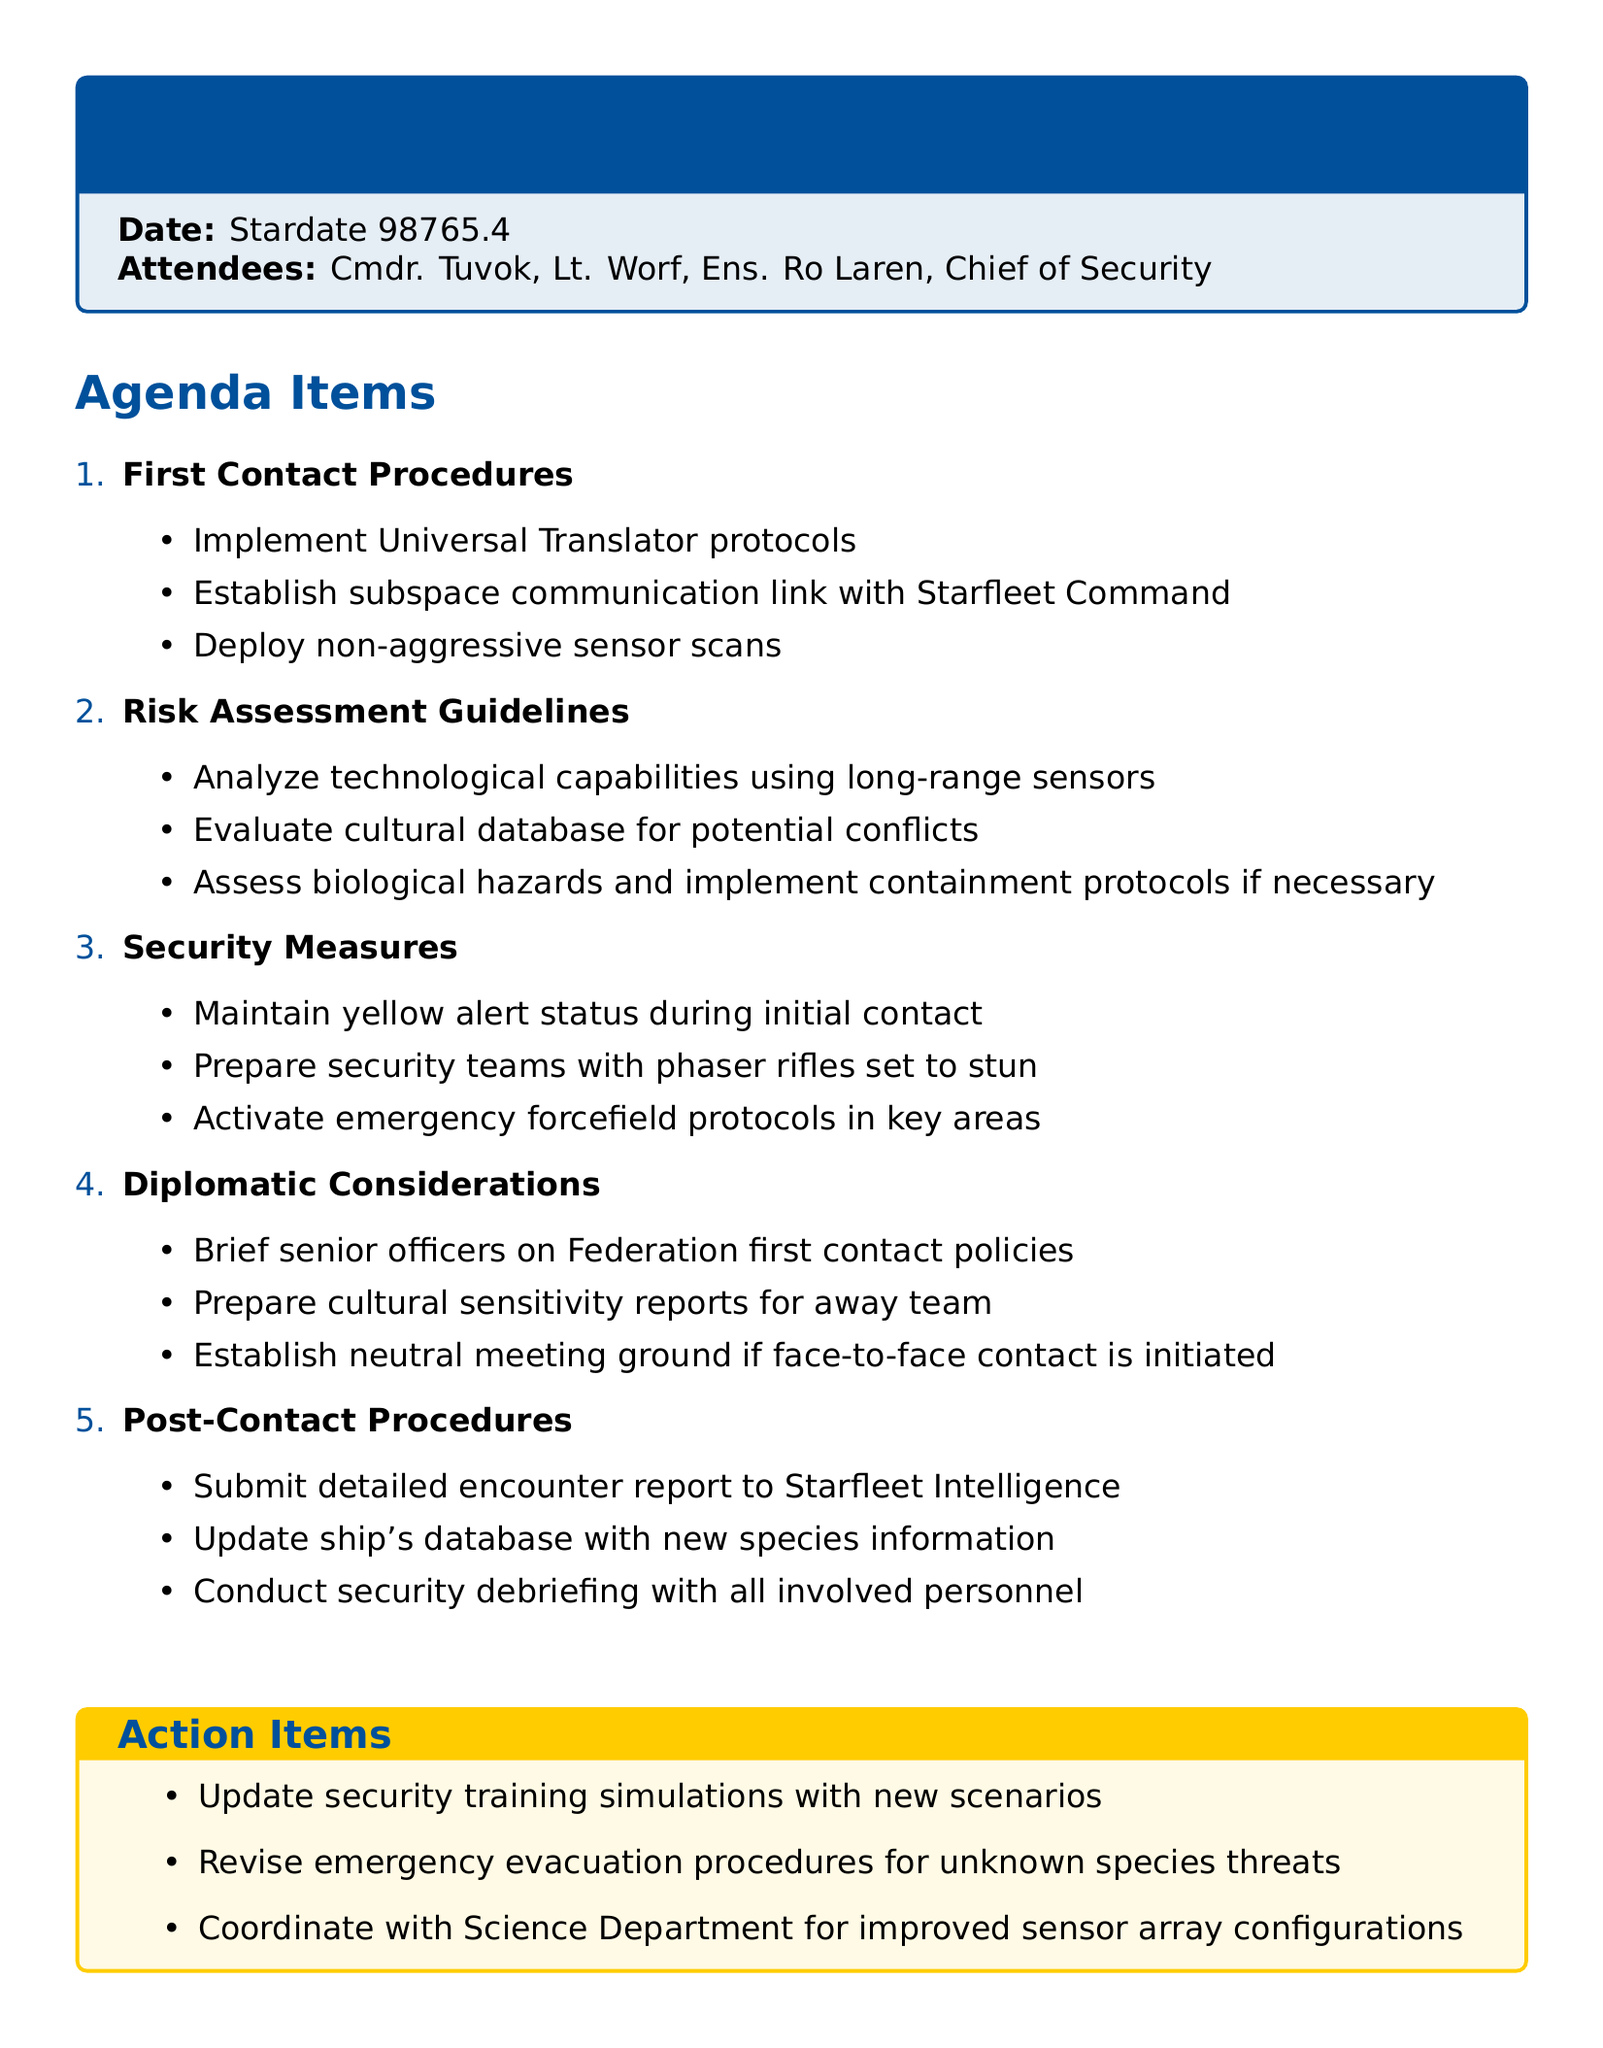What is the date of the meeting? The date of the meeting is explicitly stated in the document as Stardate 98765.4.
Answer: Stardate 98765.4 Who is the Chief of Security? The attendees of the meeting include a position labeled as Chief of Security, which is mentioned in the document.
Answer: Chief of Security What is the first item on the agenda? The first item listed in the agenda is explicitly detailed in the document as the first point.
Answer: First Contact Procedures How many points are listed under Risk Assessment Guidelines? The number of points under Risk Assessment Guidelines can be counted directly from the document.
Answer: Three What alert status should be maintained during initial contact? The document specifies that a particular alert status should be maintained during the initial contact phase.
Answer: Yellow alert What is the action item related to training simulations? The action items include a specific task related to updating training simulations mentioned in the document.
Answer: Update security training simulations with new scenarios Which department should coordinate for improved sensor configurations? The document states a specific department that should coordinate efforts regarding sensor configurations.
Answer: Science Department What should be submitted to Starfleet Intelligence after contact? The document refers to a specific report that needs to be submitted post-contact, indicating procedural compliance.
Answer: Detailed encounter report What should be prepared for the away team? The document lists a specific type of report that needs to be prepared for the away team during the diplomatic considerations.
Answer: Cultural sensitivity reports 